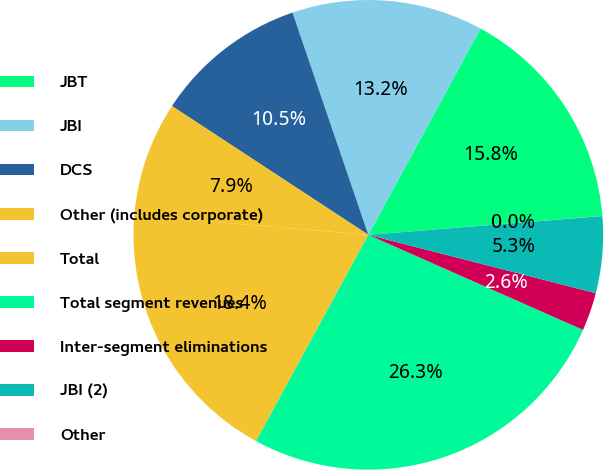<chart> <loc_0><loc_0><loc_500><loc_500><pie_chart><fcel>JBT<fcel>JBI<fcel>DCS<fcel>Other (includes corporate)<fcel>Total<fcel>Total segment revenues<fcel>Inter-segment eliminations<fcel>JBI (2)<fcel>Other<nl><fcel>15.79%<fcel>13.16%<fcel>10.53%<fcel>7.9%<fcel>18.41%<fcel>26.3%<fcel>2.64%<fcel>5.27%<fcel>0.01%<nl></chart> 